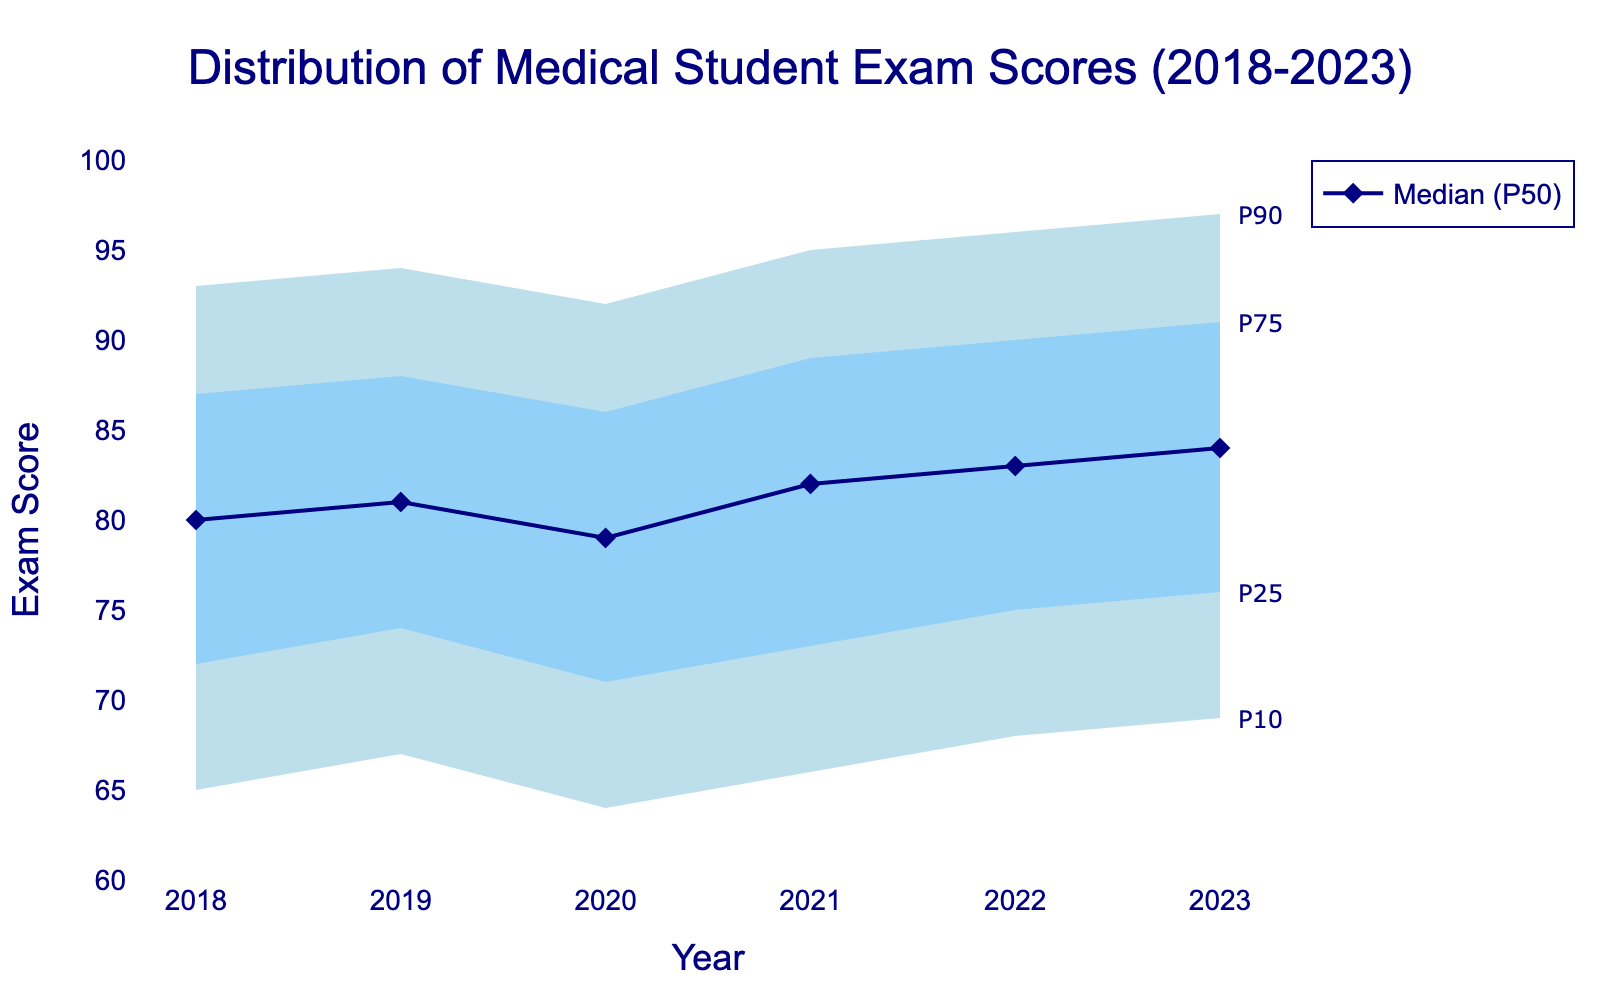What is the title of the chart? Look at the top of the chart to see the text that indicates the title of the dataset.
Answer: Distribution of Medical Student Exam Scores (2018-2023) What are the x-axis and y-axis labels? The labels for the axes indicate what the data represents. The x-axis label is below the horizontal axis, and the y-axis label is next to the vertical axis.
Answer: Year; Exam Score What colors are used to differentiate the percentile ranges in the fan chart? Notice the shaded areas in the chart that indicate different percentile ranges. The colors help to visually identify the ranges.
Answer: Light blue; Sky blue What is the median (P50) exam score in 2020? Look at the P50 data point for the year 2020 on the chart. The median line is typically marked with a marker.
Answer: 79 How did the median (P50) exam score change from 2018 to 2023? Find the median values for 2018 and 2023 and calculate the difference.
Answer: Increased by 4 Which year shows the highest P90 value? Identify the P90 values for all years and determine which year has the maximum value.
Answer: 2023 By how many points did the P75 score increase from 2018 to 2023? Compare the P75 value in 2018 to the P75 value in 2023 and find the difference.
Answer: Increased by 4 points What is the range of scores between the P25 and P75 percentiles in 2022? Subtract the P25 value from the P75 value for the year 2022 to find the interquartile range.
Answer: 15 points How did the P10 percentile score change between 2018 and 2020? Compare the P10 values for the years 2018 and 2020 and calculate the difference.
Answer: Decreased by 1 point Which percentile shows an increasing trend every year from 2018 to 2023? Review the chart to identify the percentile whose values consistently increase each year.
Answer: P50 